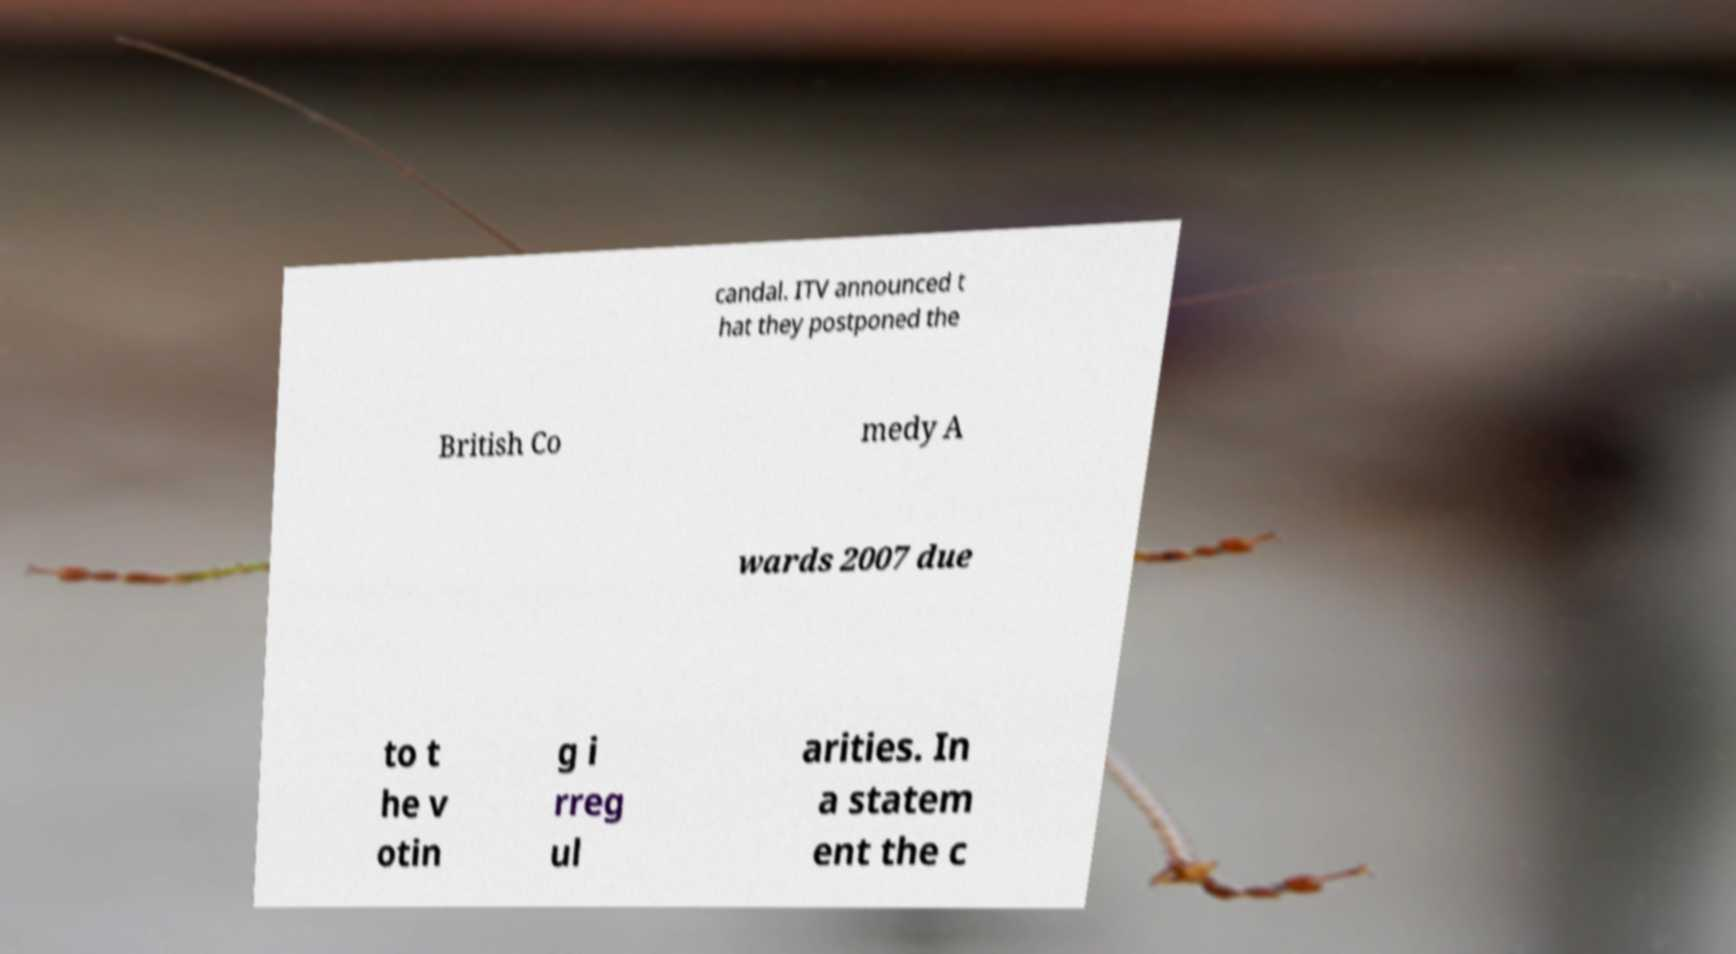I need the written content from this picture converted into text. Can you do that? candal. ITV announced t hat they postponed the British Co medy A wards 2007 due to t he v otin g i rreg ul arities. In a statem ent the c 